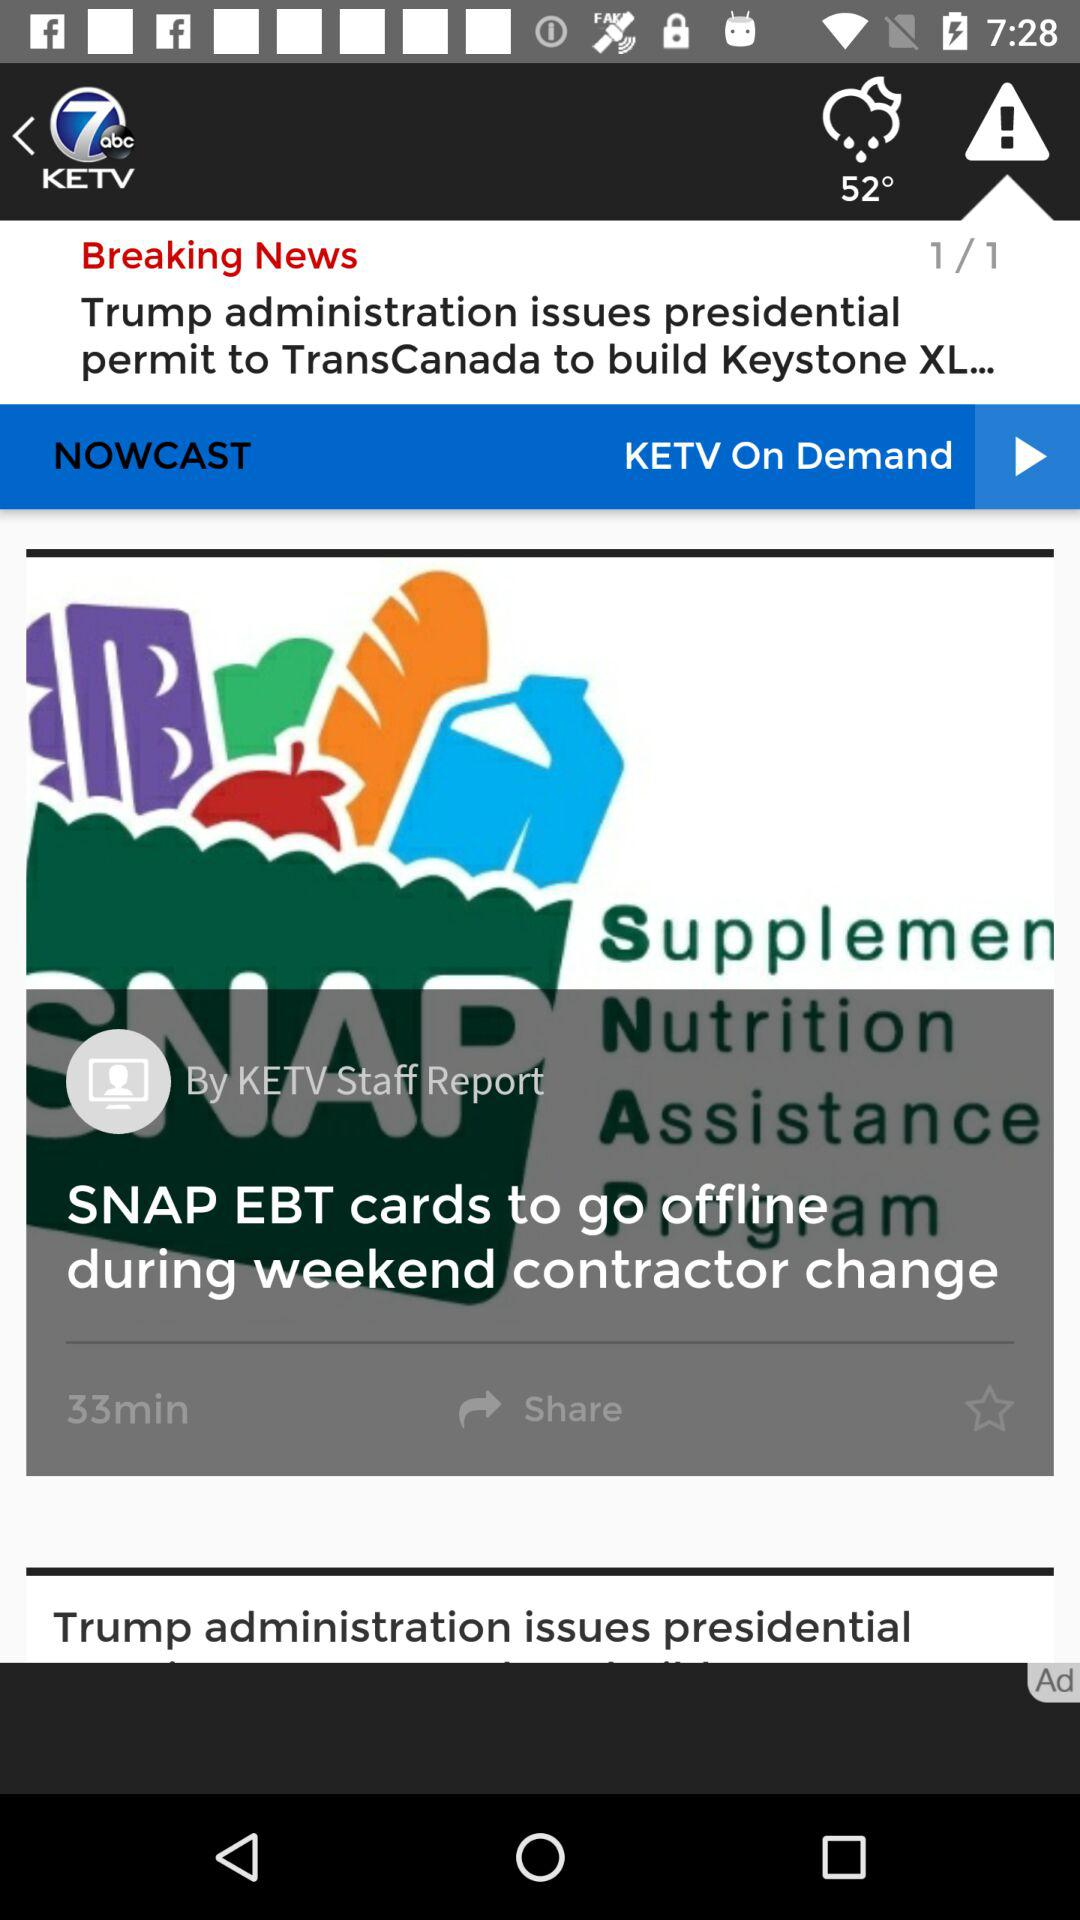What is the application name? The application name is "KETV 7 News and Weather". 